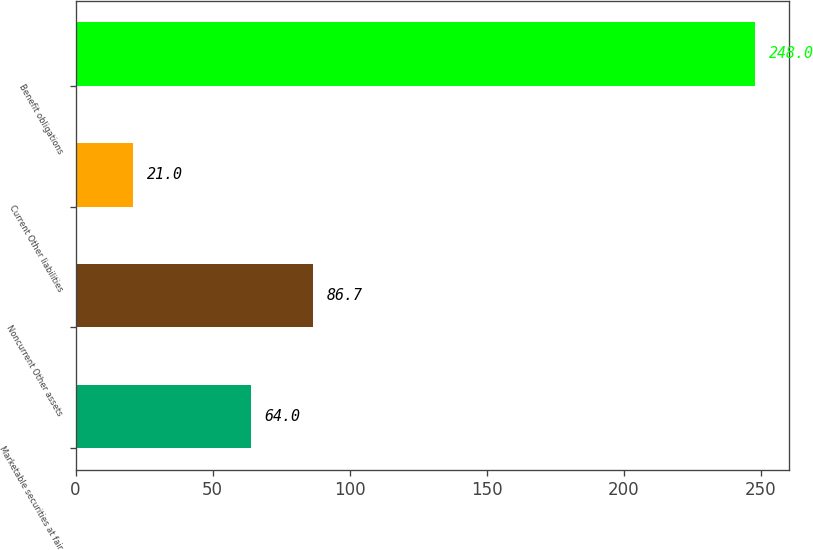<chart> <loc_0><loc_0><loc_500><loc_500><bar_chart><fcel>Marketable securities at fair<fcel>Noncurrent Other assets<fcel>Current Other liabilities<fcel>Benefit obligations<nl><fcel>64<fcel>86.7<fcel>21<fcel>248<nl></chart> 